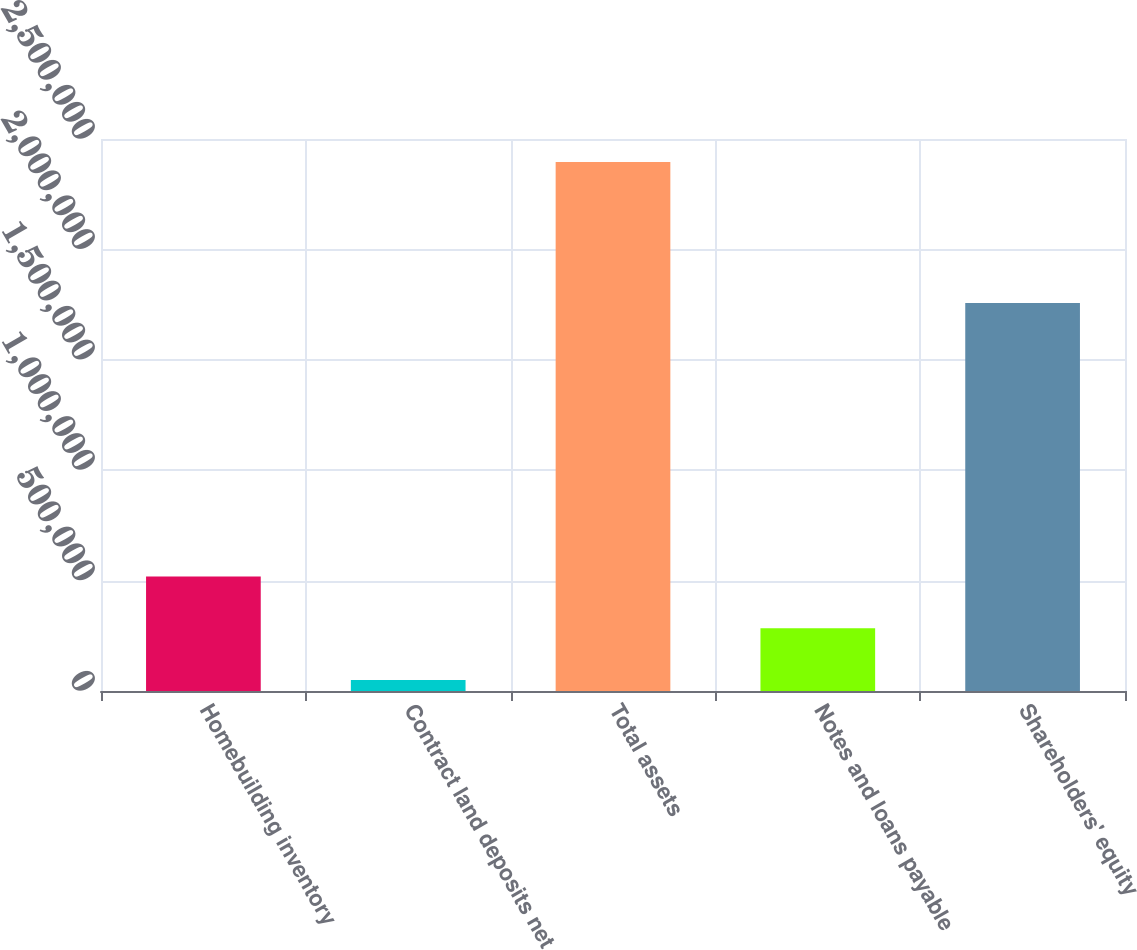<chart> <loc_0><loc_0><loc_500><loc_500><bar_chart><fcel>Homebuilding inventory<fcel>Contract land deposits net<fcel>Total assets<fcel>Notes and loans payable<fcel>Shareholders' equity<nl><fcel>519079<fcel>49906<fcel>2.39577e+06<fcel>284492<fcel>1.75726e+06<nl></chart> 